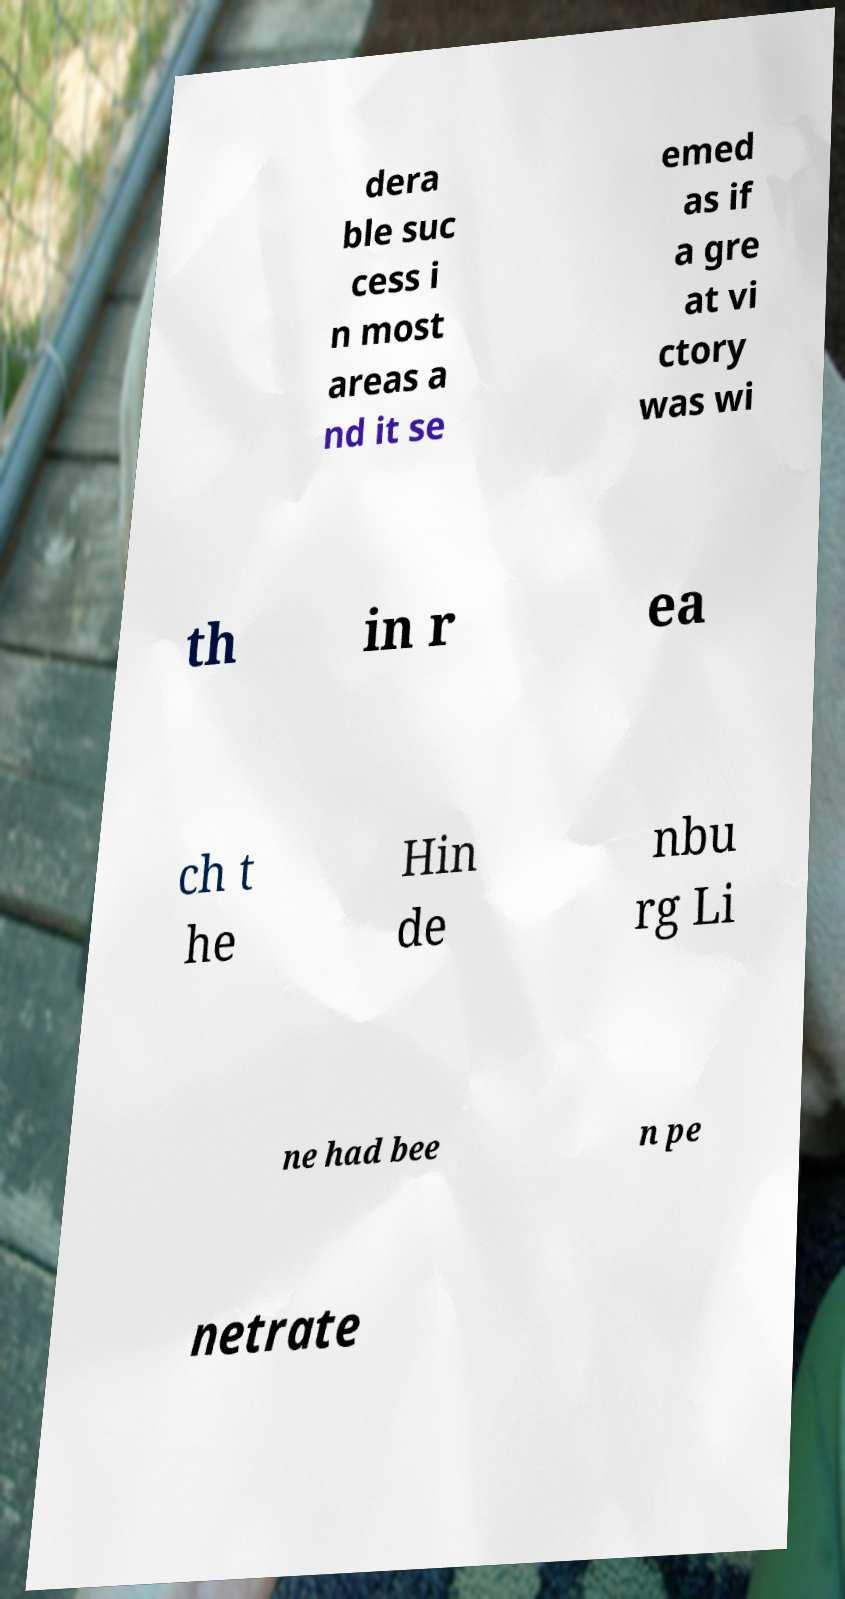Could you extract and type out the text from this image? dera ble suc cess i n most areas a nd it se emed as if a gre at vi ctory was wi th in r ea ch t he Hin de nbu rg Li ne had bee n pe netrate 